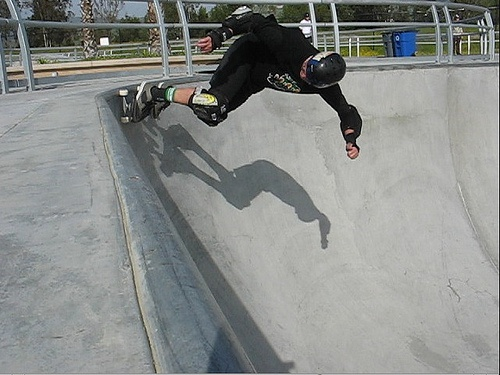Describe the objects in this image and their specific colors. I can see people in gray, black, darkgray, and lightgray tones, skateboard in gray, black, darkgray, and lightgray tones, people in gray, black, darkgray, and lightgray tones, and people in gray, lavender, darkgray, and black tones in this image. 